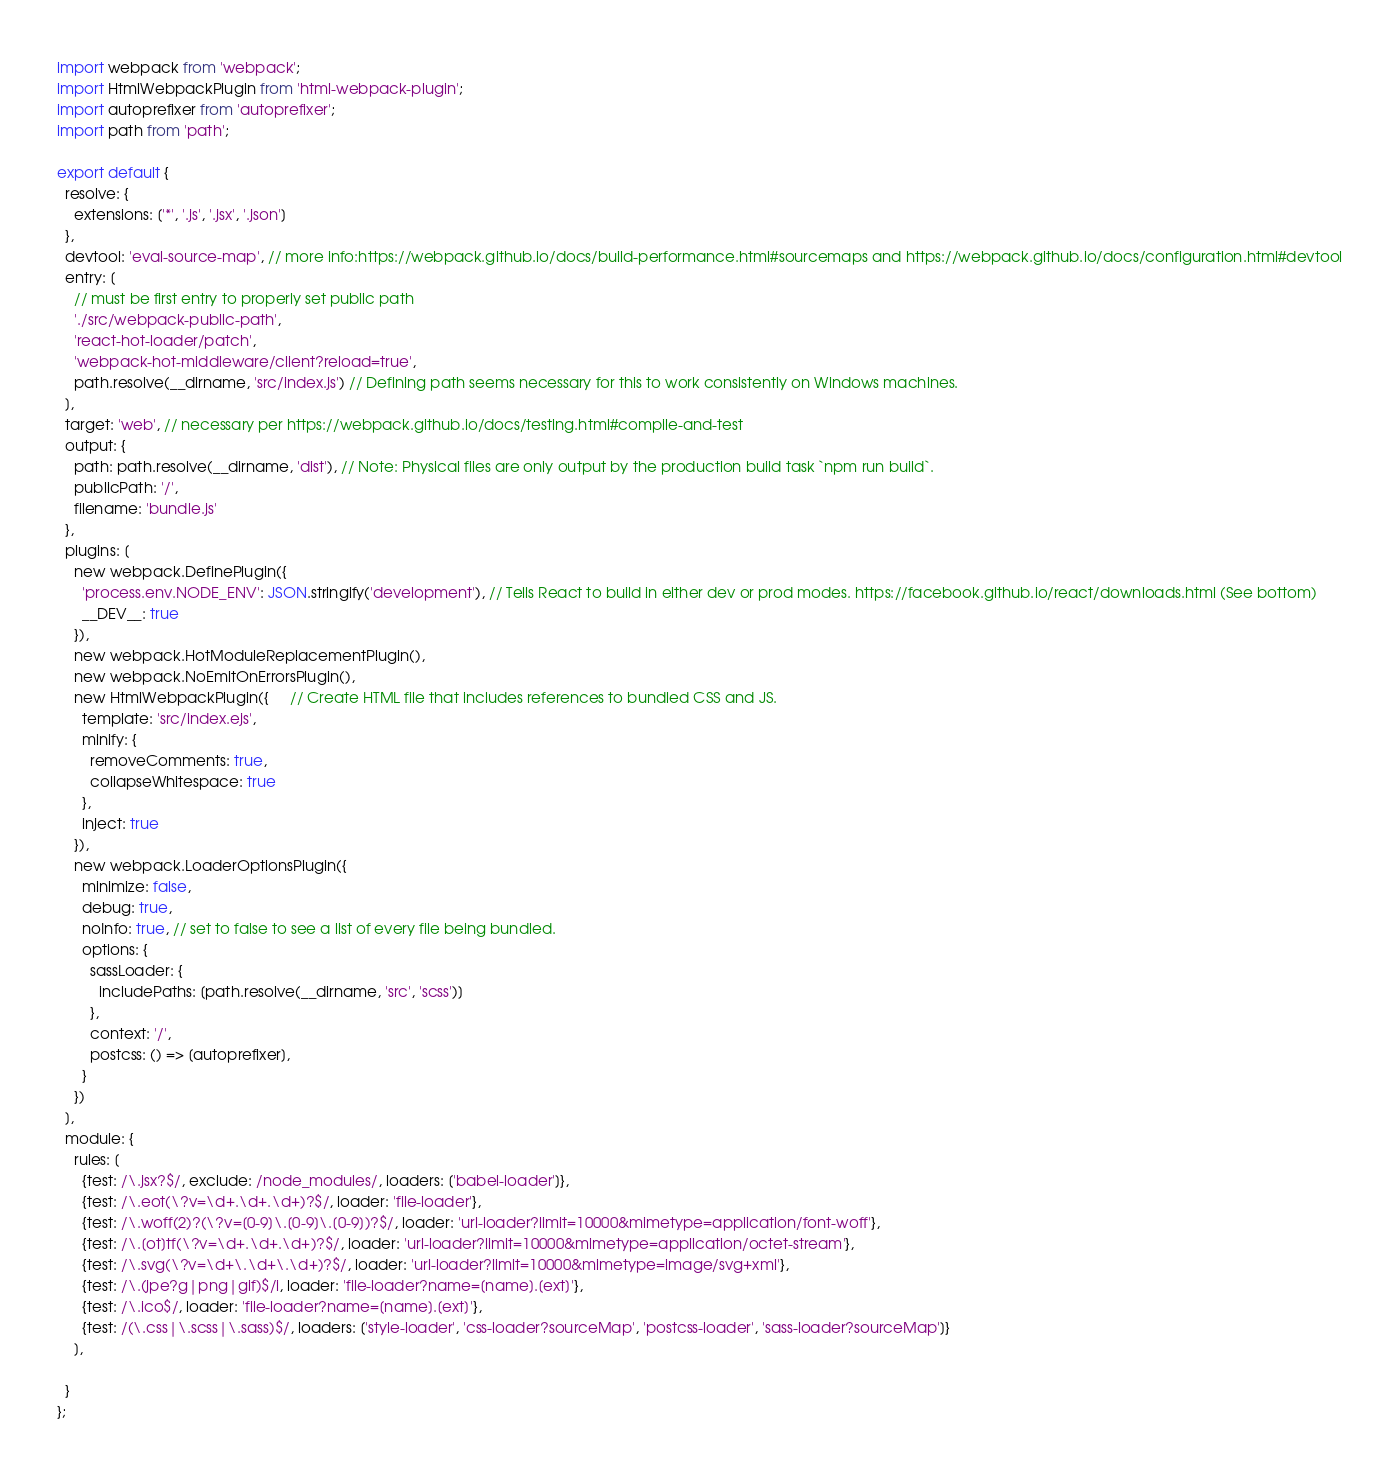Convert code to text. <code><loc_0><loc_0><loc_500><loc_500><_JavaScript_>import webpack from 'webpack';
import HtmlWebpackPlugin from 'html-webpack-plugin';
import autoprefixer from 'autoprefixer';
import path from 'path';

export default {
  resolve: {
    extensions: ['*', '.js', '.jsx', '.json']
  },
  devtool: 'eval-source-map', // more info:https://webpack.github.io/docs/build-performance.html#sourcemaps and https://webpack.github.io/docs/configuration.html#devtool
  entry: [
    // must be first entry to properly set public path
    './src/webpack-public-path',
    'react-hot-loader/patch',
    'webpack-hot-middleware/client?reload=true',
    path.resolve(__dirname, 'src/index.js') // Defining path seems necessary for this to work consistently on Windows machines.
  ],
  target: 'web', // necessary per https://webpack.github.io/docs/testing.html#compile-and-test
  output: {
    path: path.resolve(__dirname, 'dist'), // Note: Physical files are only output by the production build task `npm run build`.
    publicPath: '/',
    filename: 'bundle.js'
  },
  plugins: [
    new webpack.DefinePlugin({
      'process.env.NODE_ENV': JSON.stringify('development'), // Tells React to build in either dev or prod modes. https://facebook.github.io/react/downloads.html (See bottom)
      __DEV__: true
    }),
    new webpack.HotModuleReplacementPlugin(),
    new webpack.NoEmitOnErrorsPlugin(),
    new HtmlWebpackPlugin({     // Create HTML file that includes references to bundled CSS and JS.
      template: 'src/index.ejs',
      minify: {
        removeComments: true,
        collapseWhitespace: true
      },
      inject: true
    }),
    new webpack.LoaderOptionsPlugin({
      minimize: false,
      debug: true,
      noInfo: true, // set to false to see a list of every file being bundled.
      options: {
        sassLoader: {
          includePaths: [path.resolve(__dirname, 'src', 'scss')]
        },
        context: '/',
        postcss: () => [autoprefixer],
      }
    })
  ],
  module: {
    rules: [
      {test: /\.jsx?$/, exclude: /node_modules/, loaders: ['babel-loader']},
      {test: /\.eot(\?v=\d+.\d+.\d+)?$/, loader: 'file-loader'},
      {test: /\.woff(2)?(\?v=[0-9]\.[0-9]\.[0-9])?$/, loader: 'url-loader?limit=10000&mimetype=application/font-woff'},
      {test: /\.[ot]tf(\?v=\d+.\d+.\d+)?$/, loader: 'url-loader?limit=10000&mimetype=application/octet-stream'},
      {test: /\.svg(\?v=\d+\.\d+\.\d+)?$/, loader: 'url-loader?limit=10000&mimetype=image/svg+xml'},
      {test: /\.(jpe?g|png|gif)$/i, loader: 'file-loader?name=[name].[ext]'},
      {test: /\.ico$/, loader: 'file-loader?name=[name].[ext]'},
      {test: /(\.css|\.scss|\.sass)$/, loaders: ['style-loader', 'css-loader?sourceMap', 'postcss-loader', 'sass-loader?sourceMap']}
    ],
    
  }
};

</code> 